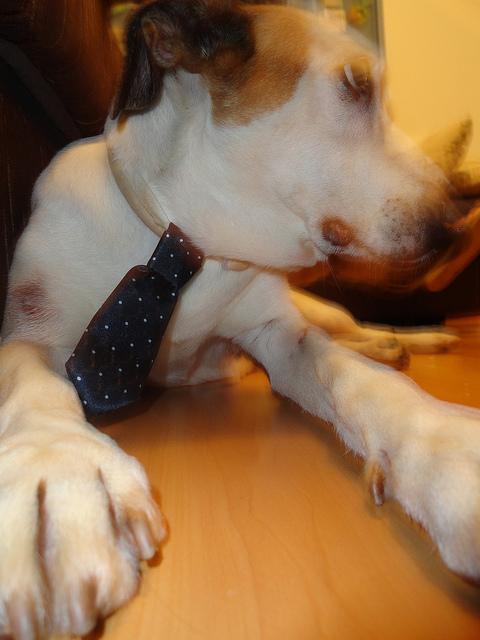Is this normal attire for a dog?
Give a very brief answer. No. What is the dog resting on?
Keep it brief. Floor. Is the dog sitting up or laying down?
Give a very brief answer. Laying down. What is the black box around the dog's neck for?
Concise answer only. Tracking. Is the dog's tongue out?
Quick response, please. No. Is this photograph in focus?
Give a very brief answer. No. Does the dog look like he's sleeping?
Answer briefly. No. What is the dog on?
Give a very brief answer. Floor. 